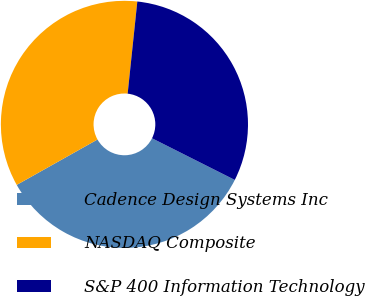Convert chart to OTSL. <chart><loc_0><loc_0><loc_500><loc_500><pie_chart><fcel>Cadence Design Systems Inc<fcel>NASDAQ Composite<fcel>S&P 400 Information Technology<nl><fcel>34.43%<fcel>34.81%<fcel>30.76%<nl></chart> 